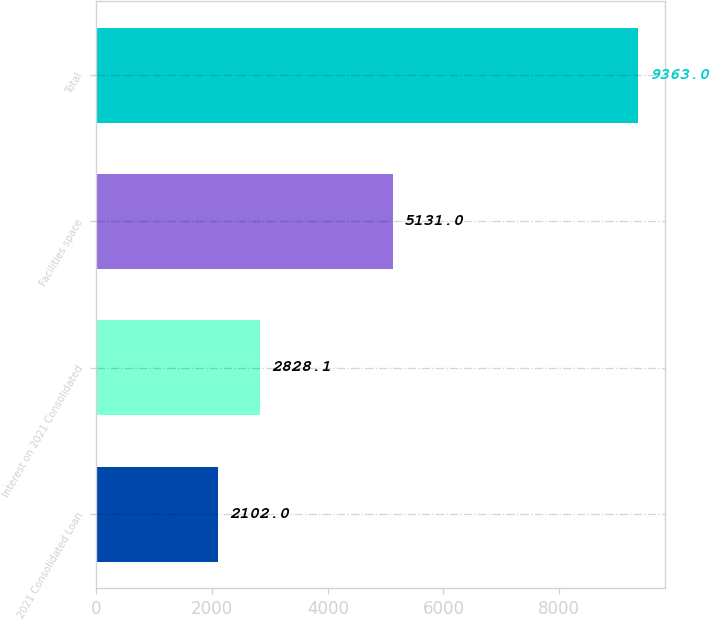Convert chart. <chart><loc_0><loc_0><loc_500><loc_500><bar_chart><fcel>2021 Consolidated Loan<fcel>Interest on 2021 Consolidated<fcel>Facilities space<fcel>Total<nl><fcel>2102<fcel>2828.1<fcel>5131<fcel>9363<nl></chart> 